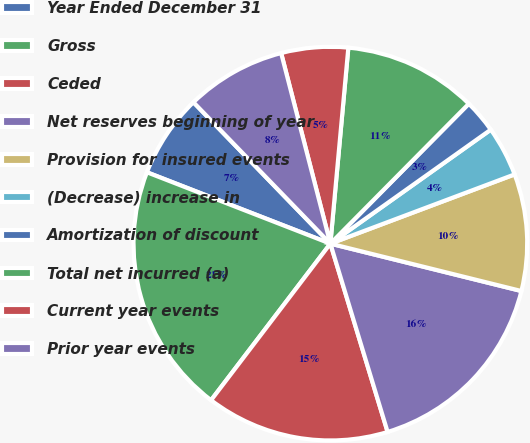Convert chart. <chart><loc_0><loc_0><loc_500><loc_500><pie_chart><fcel>Year Ended December 31<fcel>Gross<fcel>Ceded<fcel>Net reserves beginning of year<fcel>Provision for insured events<fcel>(Decrease) increase in<fcel>Amortization of discount<fcel>Total net incurred (a)<fcel>Current year events<fcel>Prior year events<nl><fcel>6.85%<fcel>20.54%<fcel>15.06%<fcel>16.43%<fcel>9.59%<fcel>4.11%<fcel>2.75%<fcel>10.96%<fcel>5.48%<fcel>8.22%<nl></chart> 